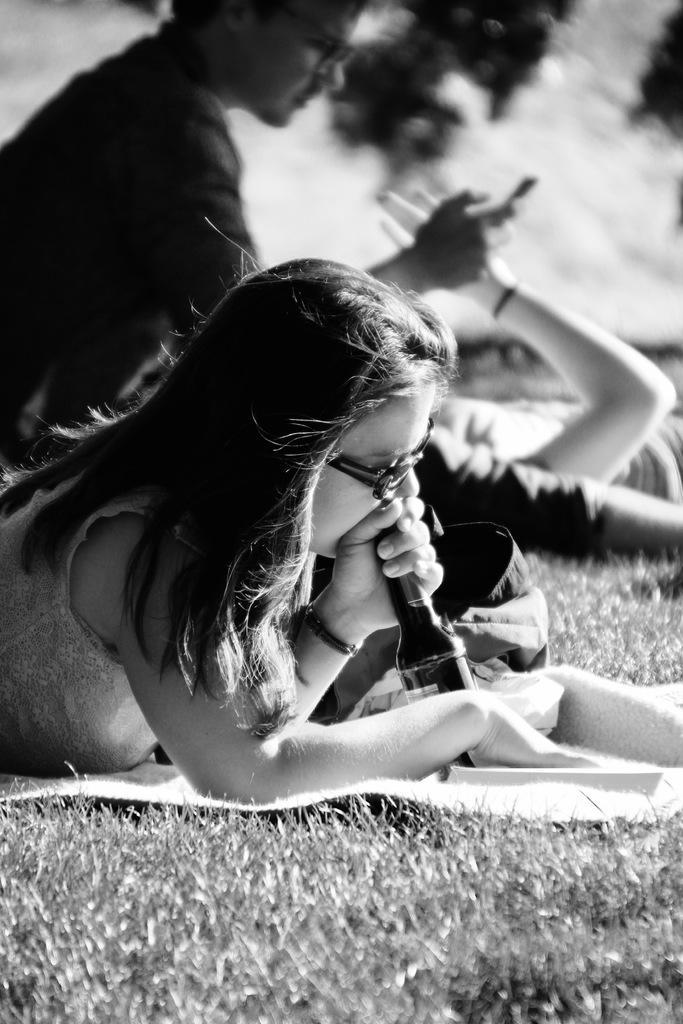How would you summarize this image in a sentence or two? It is a black and white image. In this image we can see a woman wearing the glasses and holding the bottle and also lying on the cloth which is on the grass. In the background we can see two persons. 